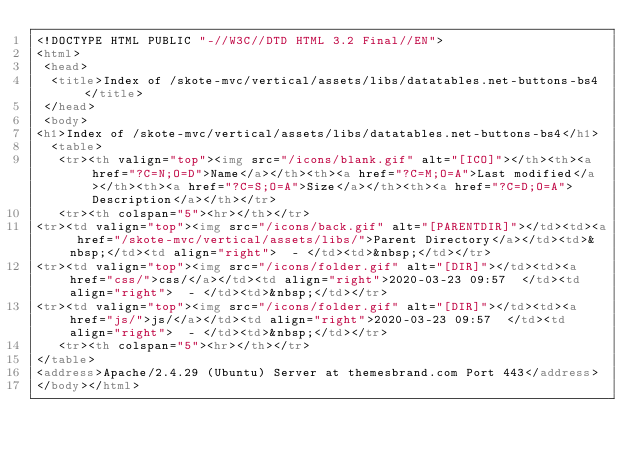<code> <loc_0><loc_0><loc_500><loc_500><_HTML_><!DOCTYPE HTML PUBLIC "-//W3C//DTD HTML 3.2 Final//EN">
<html>
 <head>
  <title>Index of /skote-mvc/vertical/assets/libs/datatables.net-buttons-bs4</title>
 </head>
 <body>
<h1>Index of /skote-mvc/vertical/assets/libs/datatables.net-buttons-bs4</h1>
  <table>
   <tr><th valign="top"><img src="/icons/blank.gif" alt="[ICO]"></th><th><a href="?C=N;O=D">Name</a></th><th><a href="?C=M;O=A">Last modified</a></th><th><a href="?C=S;O=A">Size</a></th><th><a href="?C=D;O=A">Description</a></th></tr>
   <tr><th colspan="5"><hr></th></tr>
<tr><td valign="top"><img src="/icons/back.gif" alt="[PARENTDIR]"></td><td><a href="/skote-mvc/vertical/assets/libs/">Parent Directory</a></td><td>&nbsp;</td><td align="right">  - </td><td>&nbsp;</td></tr>
<tr><td valign="top"><img src="/icons/folder.gif" alt="[DIR]"></td><td><a href="css/">css/</a></td><td align="right">2020-03-23 09:57  </td><td align="right">  - </td><td>&nbsp;</td></tr>
<tr><td valign="top"><img src="/icons/folder.gif" alt="[DIR]"></td><td><a href="js/">js/</a></td><td align="right">2020-03-23 09:57  </td><td align="right">  - </td><td>&nbsp;</td></tr>
   <tr><th colspan="5"><hr></th></tr>
</table>
<address>Apache/2.4.29 (Ubuntu) Server at themesbrand.com Port 443</address>
</body></html>
</code> 